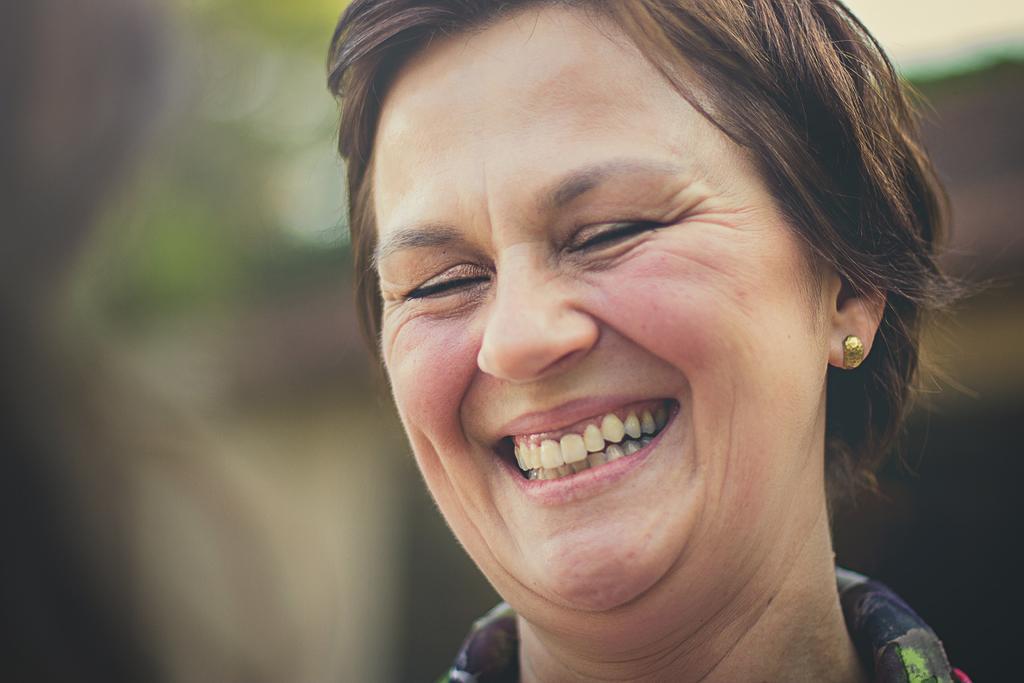In one or two sentences, can you explain what this image depicts? In this image we can see there is a person with smiling face and blur background. 